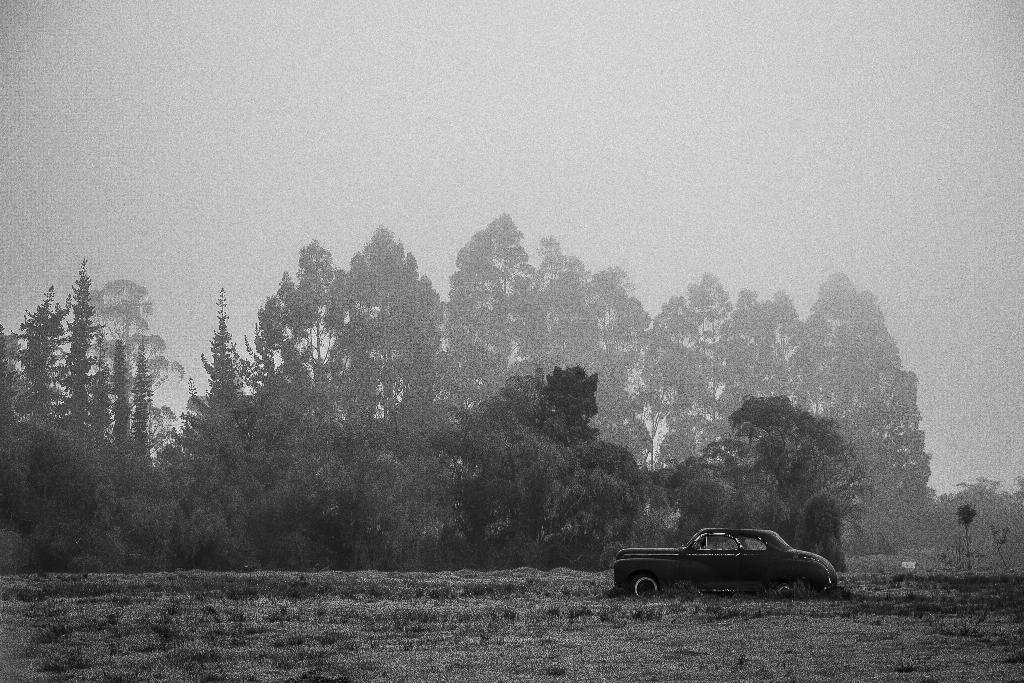What is the main subject of the image? The main subject of the image is a car. Where is the car located in the image? The car is on the ground in the image. What can be seen in the background of the image? There are trees and the sky visible in the background of the image. How does the car express love in the image? The car does not express love in the image, as it is an inanimate object and cannot experience emotions. 